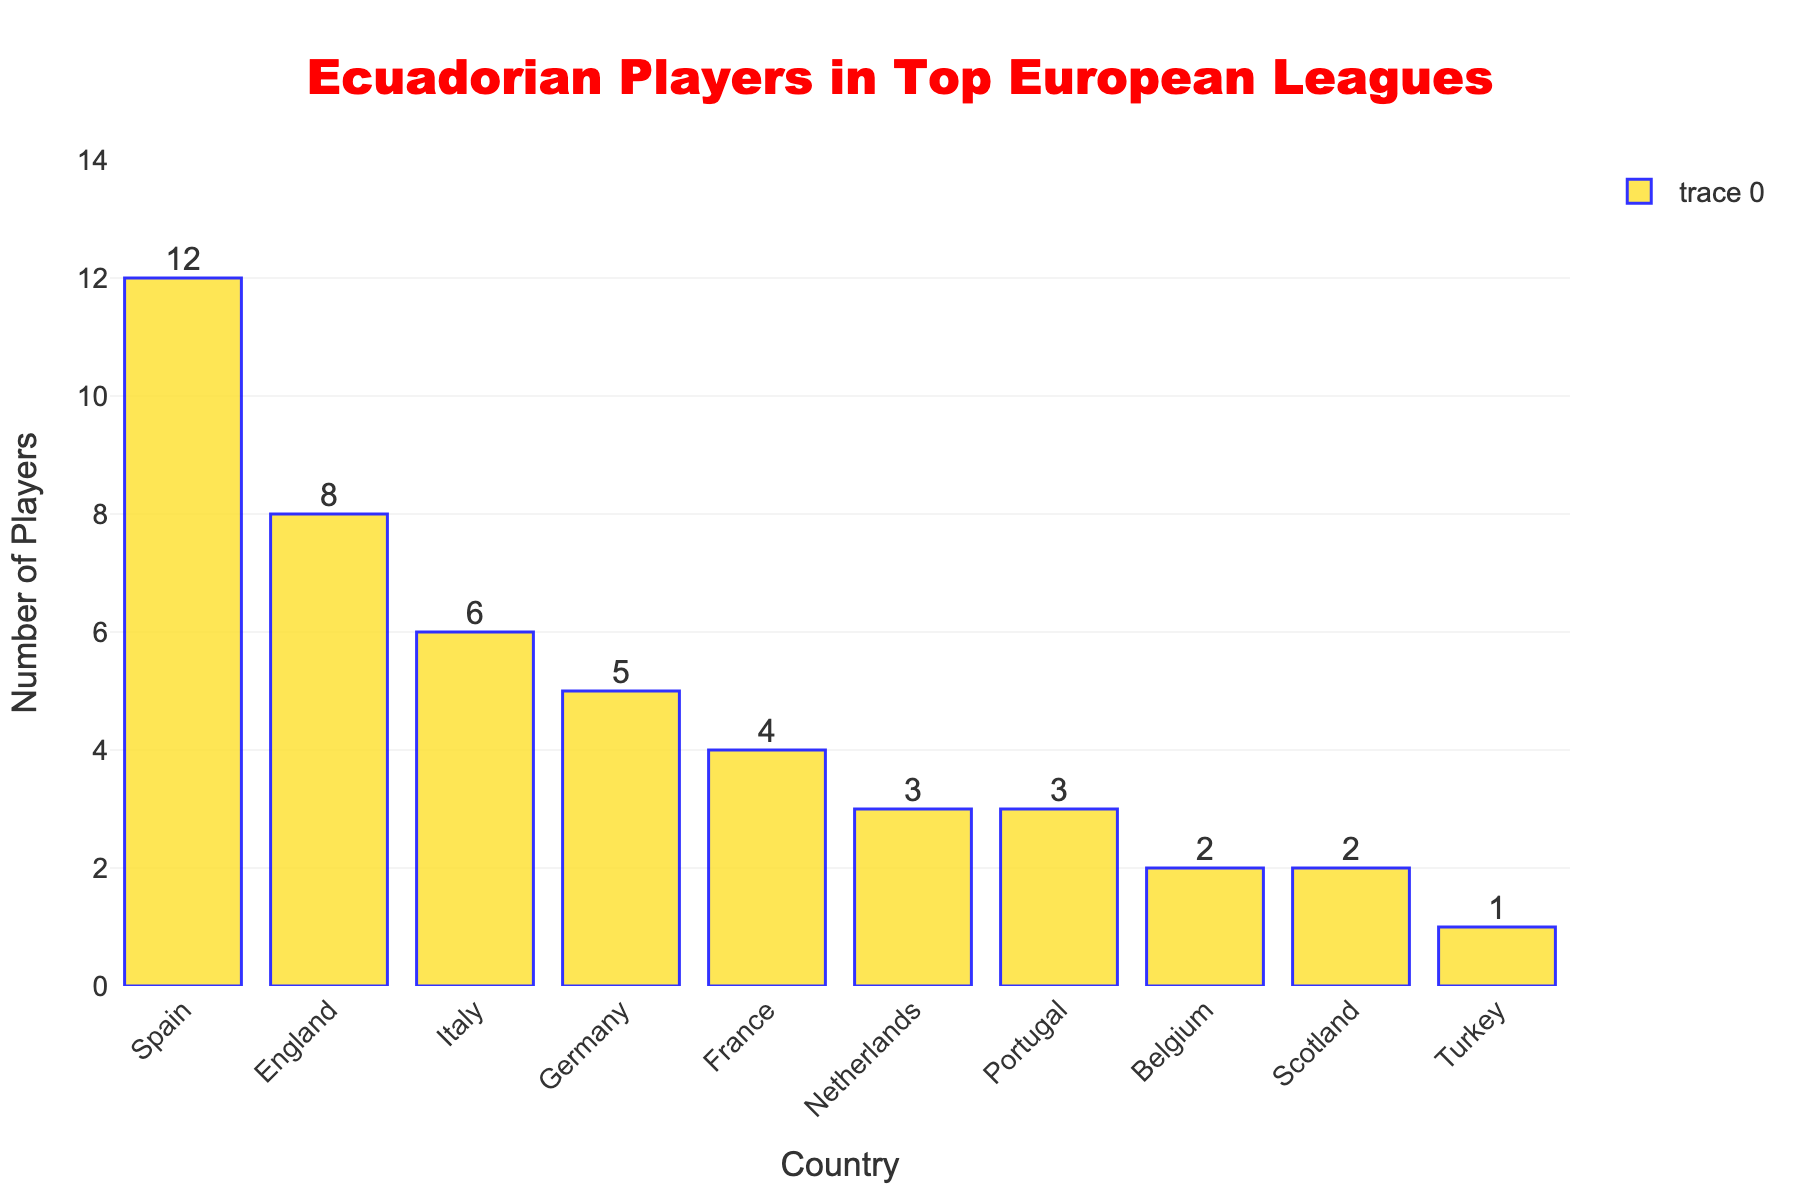Which country has the highest number of Ecuadorian players? By observing the heights of the bars, we see that Spain has the tallest bar, indicating it has the highest number of Ecuadorian players.
Answer: Spain Which two countries have the same number of Ecuadorian players? By looking closely at the bars, we see that the heights are equal for the Netherlands and Portugal, both have 3 players each.
Answer: Netherlands and Portugal What is the total number of Ecuadorian players in Germany, France, and Italy? Add the number of players in Germany (5), France (4), and Italy (6): 5 + 4 + 6 = 15.
Answer: 15 Which country has fewer Ecuadorian players, Belgium or Scotland? By comparing the heights of the bars for Belgium and Scotland, we see that Belgium has 2 players and Scotland also has 2 players.
Answer: They have the same number Are there more Ecuadorian players in England or in Italy? Compare the height of the bars for England and Italy; England has a taller bar with 8 players compared to Italy which has 6.
Answer: England How many more Ecuadorian players are there in Spain compared to Turkey? Spain has 12 players and Turkey has 1; the difference is 12 - 1 = 11.
Answer: 11 What is the median number of Ecuadorian players in these countries? First, order the numbers: 1, 2, 2, 3, 3, 4, 5, 6, 8, 12. The median is the average of the 5th and 6th values: (3 + 4) / 2 = 3.5.
Answer: 3.5 Which country has the closest number of Ecuadorian players to the average number across all these countries? The average is calculated as total number of players divided by number of countries. Total: 46, Number of countries: 10, Average: 46 / 10 = 4.6. France has 4 players, which is closest to 4.6.
Answer: France 